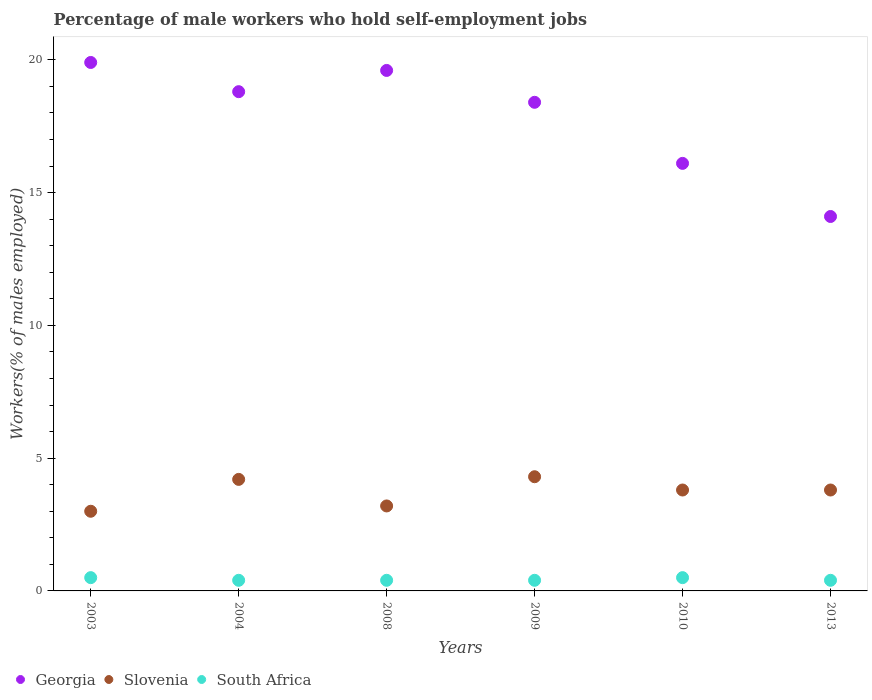How many different coloured dotlines are there?
Make the answer very short. 3. Across all years, what is the maximum percentage of self-employed male workers in Georgia?
Offer a very short reply. 19.9. Across all years, what is the minimum percentage of self-employed male workers in South Africa?
Keep it short and to the point. 0.4. In which year was the percentage of self-employed male workers in South Africa maximum?
Offer a very short reply. 2003. What is the total percentage of self-employed male workers in South Africa in the graph?
Provide a short and direct response. 2.6. What is the difference between the percentage of self-employed male workers in Slovenia in 2009 and that in 2010?
Provide a short and direct response. 0.5. What is the difference between the percentage of self-employed male workers in Slovenia in 2004 and the percentage of self-employed male workers in South Africa in 2009?
Your response must be concise. 3.8. What is the average percentage of self-employed male workers in South Africa per year?
Ensure brevity in your answer.  0.43. In the year 2008, what is the difference between the percentage of self-employed male workers in South Africa and percentage of self-employed male workers in Georgia?
Your response must be concise. -19.2. What is the ratio of the percentage of self-employed male workers in Georgia in 2003 to that in 2013?
Offer a terse response. 1.41. Is the percentage of self-employed male workers in Slovenia in 2003 less than that in 2013?
Your response must be concise. Yes. What is the difference between the highest and the second highest percentage of self-employed male workers in Georgia?
Your answer should be compact. 0.3. What is the difference between the highest and the lowest percentage of self-employed male workers in Georgia?
Ensure brevity in your answer.  5.8. Is it the case that in every year, the sum of the percentage of self-employed male workers in Slovenia and percentage of self-employed male workers in South Africa  is greater than the percentage of self-employed male workers in Georgia?
Your response must be concise. No. Does the percentage of self-employed male workers in Georgia monotonically increase over the years?
Make the answer very short. No. Does the graph contain any zero values?
Make the answer very short. No. How many legend labels are there?
Your response must be concise. 3. What is the title of the graph?
Provide a succinct answer. Percentage of male workers who hold self-employment jobs. What is the label or title of the X-axis?
Keep it short and to the point. Years. What is the label or title of the Y-axis?
Give a very brief answer. Workers(% of males employed). What is the Workers(% of males employed) of Georgia in 2003?
Your answer should be compact. 19.9. What is the Workers(% of males employed) of Georgia in 2004?
Offer a very short reply. 18.8. What is the Workers(% of males employed) of Slovenia in 2004?
Provide a succinct answer. 4.2. What is the Workers(% of males employed) in South Africa in 2004?
Make the answer very short. 0.4. What is the Workers(% of males employed) of Georgia in 2008?
Provide a short and direct response. 19.6. What is the Workers(% of males employed) in Slovenia in 2008?
Provide a succinct answer. 3.2. What is the Workers(% of males employed) in South Africa in 2008?
Give a very brief answer. 0.4. What is the Workers(% of males employed) in Georgia in 2009?
Offer a very short reply. 18.4. What is the Workers(% of males employed) of Slovenia in 2009?
Provide a succinct answer. 4.3. What is the Workers(% of males employed) of South Africa in 2009?
Provide a short and direct response. 0.4. What is the Workers(% of males employed) of Georgia in 2010?
Offer a terse response. 16.1. What is the Workers(% of males employed) of Slovenia in 2010?
Offer a very short reply. 3.8. What is the Workers(% of males employed) in Georgia in 2013?
Provide a succinct answer. 14.1. What is the Workers(% of males employed) in Slovenia in 2013?
Give a very brief answer. 3.8. What is the Workers(% of males employed) in South Africa in 2013?
Make the answer very short. 0.4. Across all years, what is the maximum Workers(% of males employed) in Georgia?
Offer a terse response. 19.9. Across all years, what is the maximum Workers(% of males employed) of Slovenia?
Offer a terse response. 4.3. Across all years, what is the minimum Workers(% of males employed) in Georgia?
Provide a succinct answer. 14.1. Across all years, what is the minimum Workers(% of males employed) of Slovenia?
Keep it short and to the point. 3. Across all years, what is the minimum Workers(% of males employed) in South Africa?
Give a very brief answer. 0.4. What is the total Workers(% of males employed) in Georgia in the graph?
Offer a very short reply. 106.9. What is the total Workers(% of males employed) of Slovenia in the graph?
Offer a terse response. 22.3. What is the difference between the Workers(% of males employed) in Georgia in 2003 and that in 2004?
Keep it short and to the point. 1.1. What is the difference between the Workers(% of males employed) in Slovenia in 2003 and that in 2004?
Give a very brief answer. -1.2. What is the difference between the Workers(% of males employed) of South Africa in 2003 and that in 2004?
Your answer should be very brief. 0.1. What is the difference between the Workers(% of males employed) of Slovenia in 2003 and that in 2008?
Offer a very short reply. -0.2. What is the difference between the Workers(% of males employed) in Slovenia in 2003 and that in 2009?
Ensure brevity in your answer.  -1.3. What is the difference between the Workers(% of males employed) of South Africa in 2003 and that in 2009?
Offer a terse response. 0.1. What is the difference between the Workers(% of males employed) of Georgia in 2003 and that in 2010?
Your answer should be very brief. 3.8. What is the difference between the Workers(% of males employed) in Slovenia in 2003 and that in 2010?
Offer a very short reply. -0.8. What is the difference between the Workers(% of males employed) of Georgia in 2003 and that in 2013?
Keep it short and to the point. 5.8. What is the difference between the Workers(% of males employed) in South Africa in 2003 and that in 2013?
Provide a succinct answer. 0.1. What is the difference between the Workers(% of males employed) in Slovenia in 2004 and that in 2009?
Offer a terse response. -0.1. What is the difference between the Workers(% of males employed) of South Africa in 2004 and that in 2009?
Ensure brevity in your answer.  0. What is the difference between the Workers(% of males employed) of South Africa in 2004 and that in 2010?
Give a very brief answer. -0.1. What is the difference between the Workers(% of males employed) in Georgia in 2004 and that in 2013?
Ensure brevity in your answer.  4.7. What is the difference between the Workers(% of males employed) of Slovenia in 2004 and that in 2013?
Your response must be concise. 0.4. What is the difference between the Workers(% of males employed) of South Africa in 2004 and that in 2013?
Provide a succinct answer. 0. What is the difference between the Workers(% of males employed) in Georgia in 2008 and that in 2010?
Make the answer very short. 3.5. What is the difference between the Workers(% of males employed) of South Africa in 2008 and that in 2010?
Provide a short and direct response. -0.1. What is the difference between the Workers(% of males employed) in Georgia in 2008 and that in 2013?
Provide a short and direct response. 5.5. What is the difference between the Workers(% of males employed) of South Africa in 2008 and that in 2013?
Your answer should be very brief. 0. What is the difference between the Workers(% of males employed) in South Africa in 2009 and that in 2010?
Your answer should be compact. -0.1. What is the difference between the Workers(% of males employed) of Georgia in 2010 and that in 2013?
Your response must be concise. 2. What is the difference between the Workers(% of males employed) in Georgia in 2003 and the Workers(% of males employed) in Slovenia in 2008?
Provide a succinct answer. 16.7. What is the difference between the Workers(% of males employed) of Georgia in 2003 and the Workers(% of males employed) of South Africa in 2008?
Ensure brevity in your answer.  19.5. What is the difference between the Workers(% of males employed) of Georgia in 2003 and the Workers(% of males employed) of Slovenia in 2009?
Provide a short and direct response. 15.6. What is the difference between the Workers(% of males employed) in Slovenia in 2003 and the Workers(% of males employed) in South Africa in 2009?
Offer a very short reply. 2.6. What is the difference between the Workers(% of males employed) in Slovenia in 2003 and the Workers(% of males employed) in South Africa in 2010?
Ensure brevity in your answer.  2.5. What is the difference between the Workers(% of males employed) of Georgia in 2003 and the Workers(% of males employed) of Slovenia in 2013?
Provide a succinct answer. 16.1. What is the difference between the Workers(% of males employed) of Slovenia in 2003 and the Workers(% of males employed) of South Africa in 2013?
Keep it short and to the point. 2.6. What is the difference between the Workers(% of males employed) of Georgia in 2004 and the Workers(% of males employed) of Slovenia in 2008?
Make the answer very short. 15.6. What is the difference between the Workers(% of males employed) of Georgia in 2004 and the Workers(% of males employed) of South Africa in 2010?
Offer a very short reply. 18.3. What is the difference between the Workers(% of males employed) in Georgia in 2004 and the Workers(% of males employed) in South Africa in 2013?
Make the answer very short. 18.4. What is the difference between the Workers(% of males employed) of Georgia in 2008 and the Workers(% of males employed) of South Africa in 2009?
Offer a very short reply. 19.2. What is the difference between the Workers(% of males employed) in Slovenia in 2008 and the Workers(% of males employed) in South Africa in 2009?
Offer a very short reply. 2.8. What is the difference between the Workers(% of males employed) in Georgia in 2008 and the Workers(% of males employed) in Slovenia in 2010?
Your response must be concise. 15.8. What is the difference between the Workers(% of males employed) of Georgia in 2008 and the Workers(% of males employed) of South Africa in 2010?
Make the answer very short. 19.1. What is the difference between the Workers(% of males employed) in Slovenia in 2008 and the Workers(% of males employed) in South Africa in 2010?
Keep it short and to the point. 2.7. What is the difference between the Workers(% of males employed) in Georgia in 2008 and the Workers(% of males employed) in Slovenia in 2013?
Keep it short and to the point. 15.8. What is the difference between the Workers(% of males employed) in Georgia in 2008 and the Workers(% of males employed) in South Africa in 2013?
Keep it short and to the point. 19.2. What is the difference between the Workers(% of males employed) of Georgia in 2009 and the Workers(% of males employed) of South Africa in 2010?
Provide a short and direct response. 17.9. What is the difference between the Workers(% of males employed) of Slovenia in 2009 and the Workers(% of males employed) of South Africa in 2010?
Make the answer very short. 3.8. What is the difference between the Workers(% of males employed) in Georgia in 2009 and the Workers(% of males employed) in Slovenia in 2013?
Your answer should be very brief. 14.6. What is the difference between the Workers(% of males employed) of Georgia in 2010 and the Workers(% of males employed) of Slovenia in 2013?
Offer a terse response. 12.3. What is the difference between the Workers(% of males employed) in Georgia in 2010 and the Workers(% of males employed) in South Africa in 2013?
Ensure brevity in your answer.  15.7. What is the difference between the Workers(% of males employed) of Slovenia in 2010 and the Workers(% of males employed) of South Africa in 2013?
Offer a very short reply. 3.4. What is the average Workers(% of males employed) in Georgia per year?
Offer a terse response. 17.82. What is the average Workers(% of males employed) of Slovenia per year?
Ensure brevity in your answer.  3.72. What is the average Workers(% of males employed) in South Africa per year?
Your answer should be very brief. 0.43. In the year 2003, what is the difference between the Workers(% of males employed) in Georgia and Workers(% of males employed) in Slovenia?
Your response must be concise. 16.9. In the year 2003, what is the difference between the Workers(% of males employed) in Georgia and Workers(% of males employed) in South Africa?
Offer a very short reply. 19.4. In the year 2003, what is the difference between the Workers(% of males employed) in Slovenia and Workers(% of males employed) in South Africa?
Your response must be concise. 2.5. In the year 2004, what is the difference between the Workers(% of males employed) of Georgia and Workers(% of males employed) of Slovenia?
Provide a short and direct response. 14.6. In the year 2009, what is the difference between the Workers(% of males employed) of Georgia and Workers(% of males employed) of South Africa?
Offer a very short reply. 18. In the year 2009, what is the difference between the Workers(% of males employed) in Slovenia and Workers(% of males employed) in South Africa?
Ensure brevity in your answer.  3.9. In the year 2010, what is the difference between the Workers(% of males employed) in Georgia and Workers(% of males employed) in Slovenia?
Provide a short and direct response. 12.3. In the year 2010, what is the difference between the Workers(% of males employed) in Georgia and Workers(% of males employed) in South Africa?
Keep it short and to the point. 15.6. In the year 2013, what is the difference between the Workers(% of males employed) of Georgia and Workers(% of males employed) of Slovenia?
Make the answer very short. 10.3. In the year 2013, what is the difference between the Workers(% of males employed) in Georgia and Workers(% of males employed) in South Africa?
Give a very brief answer. 13.7. What is the ratio of the Workers(% of males employed) in Georgia in 2003 to that in 2004?
Ensure brevity in your answer.  1.06. What is the ratio of the Workers(% of males employed) in Slovenia in 2003 to that in 2004?
Your answer should be compact. 0.71. What is the ratio of the Workers(% of males employed) of South Africa in 2003 to that in 2004?
Provide a short and direct response. 1.25. What is the ratio of the Workers(% of males employed) in Georgia in 2003 to that in 2008?
Provide a succinct answer. 1.02. What is the ratio of the Workers(% of males employed) in Slovenia in 2003 to that in 2008?
Ensure brevity in your answer.  0.94. What is the ratio of the Workers(% of males employed) in South Africa in 2003 to that in 2008?
Provide a short and direct response. 1.25. What is the ratio of the Workers(% of males employed) of Georgia in 2003 to that in 2009?
Ensure brevity in your answer.  1.08. What is the ratio of the Workers(% of males employed) of Slovenia in 2003 to that in 2009?
Provide a succinct answer. 0.7. What is the ratio of the Workers(% of males employed) of Georgia in 2003 to that in 2010?
Offer a terse response. 1.24. What is the ratio of the Workers(% of males employed) in Slovenia in 2003 to that in 2010?
Offer a very short reply. 0.79. What is the ratio of the Workers(% of males employed) of South Africa in 2003 to that in 2010?
Make the answer very short. 1. What is the ratio of the Workers(% of males employed) of Georgia in 2003 to that in 2013?
Provide a short and direct response. 1.41. What is the ratio of the Workers(% of males employed) of Slovenia in 2003 to that in 2013?
Your response must be concise. 0.79. What is the ratio of the Workers(% of males employed) of Georgia in 2004 to that in 2008?
Ensure brevity in your answer.  0.96. What is the ratio of the Workers(% of males employed) in Slovenia in 2004 to that in 2008?
Ensure brevity in your answer.  1.31. What is the ratio of the Workers(% of males employed) of Georgia in 2004 to that in 2009?
Provide a succinct answer. 1.02. What is the ratio of the Workers(% of males employed) in Slovenia in 2004 to that in 2009?
Provide a succinct answer. 0.98. What is the ratio of the Workers(% of males employed) in Georgia in 2004 to that in 2010?
Your response must be concise. 1.17. What is the ratio of the Workers(% of males employed) of Slovenia in 2004 to that in 2010?
Keep it short and to the point. 1.11. What is the ratio of the Workers(% of males employed) of Georgia in 2004 to that in 2013?
Make the answer very short. 1.33. What is the ratio of the Workers(% of males employed) in Slovenia in 2004 to that in 2013?
Keep it short and to the point. 1.11. What is the ratio of the Workers(% of males employed) of Georgia in 2008 to that in 2009?
Offer a very short reply. 1.07. What is the ratio of the Workers(% of males employed) of Slovenia in 2008 to that in 2009?
Keep it short and to the point. 0.74. What is the ratio of the Workers(% of males employed) of Georgia in 2008 to that in 2010?
Your response must be concise. 1.22. What is the ratio of the Workers(% of males employed) of Slovenia in 2008 to that in 2010?
Provide a succinct answer. 0.84. What is the ratio of the Workers(% of males employed) of Georgia in 2008 to that in 2013?
Your response must be concise. 1.39. What is the ratio of the Workers(% of males employed) in Slovenia in 2008 to that in 2013?
Ensure brevity in your answer.  0.84. What is the ratio of the Workers(% of males employed) of South Africa in 2008 to that in 2013?
Your response must be concise. 1. What is the ratio of the Workers(% of males employed) in Slovenia in 2009 to that in 2010?
Your answer should be compact. 1.13. What is the ratio of the Workers(% of males employed) of South Africa in 2009 to that in 2010?
Keep it short and to the point. 0.8. What is the ratio of the Workers(% of males employed) in Georgia in 2009 to that in 2013?
Your answer should be very brief. 1.3. What is the ratio of the Workers(% of males employed) in Slovenia in 2009 to that in 2013?
Provide a short and direct response. 1.13. What is the ratio of the Workers(% of males employed) of Georgia in 2010 to that in 2013?
Keep it short and to the point. 1.14. What is the ratio of the Workers(% of males employed) in Slovenia in 2010 to that in 2013?
Ensure brevity in your answer.  1. What is the difference between the highest and the second highest Workers(% of males employed) in Slovenia?
Give a very brief answer. 0.1. What is the difference between the highest and the lowest Workers(% of males employed) of Slovenia?
Provide a short and direct response. 1.3. 